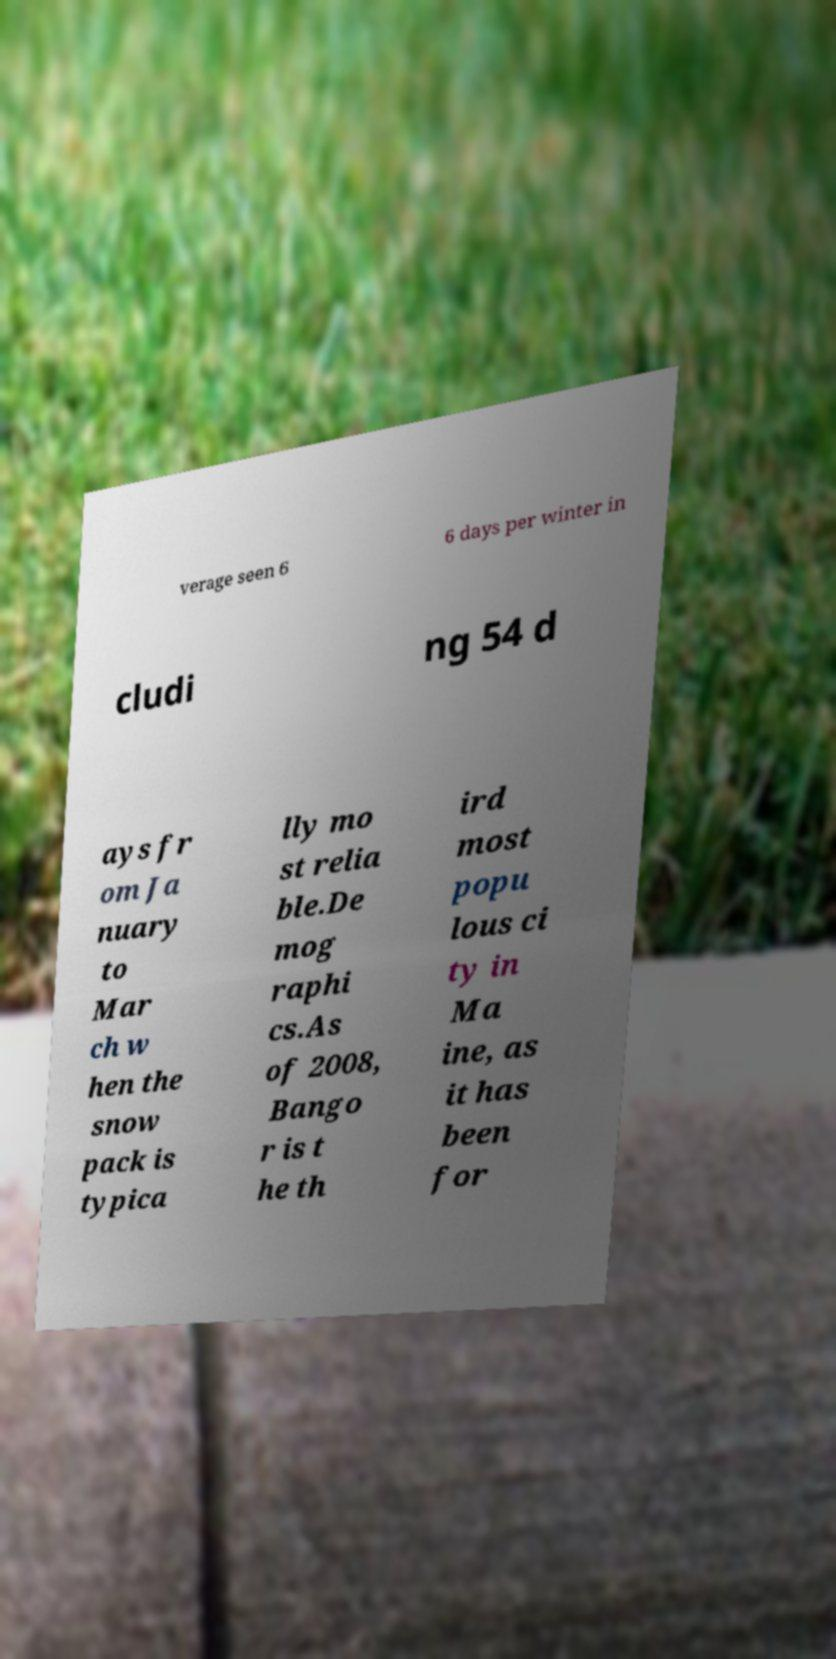Please read and relay the text visible in this image. What does it say? verage seen 6 6 days per winter in cludi ng 54 d ays fr om Ja nuary to Mar ch w hen the snow pack is typica lly mo st relia ble.De mog raphi cs.As of 2008, Bango r is t he th ird most popu lous ci ty in Ma ine, as it has been for 